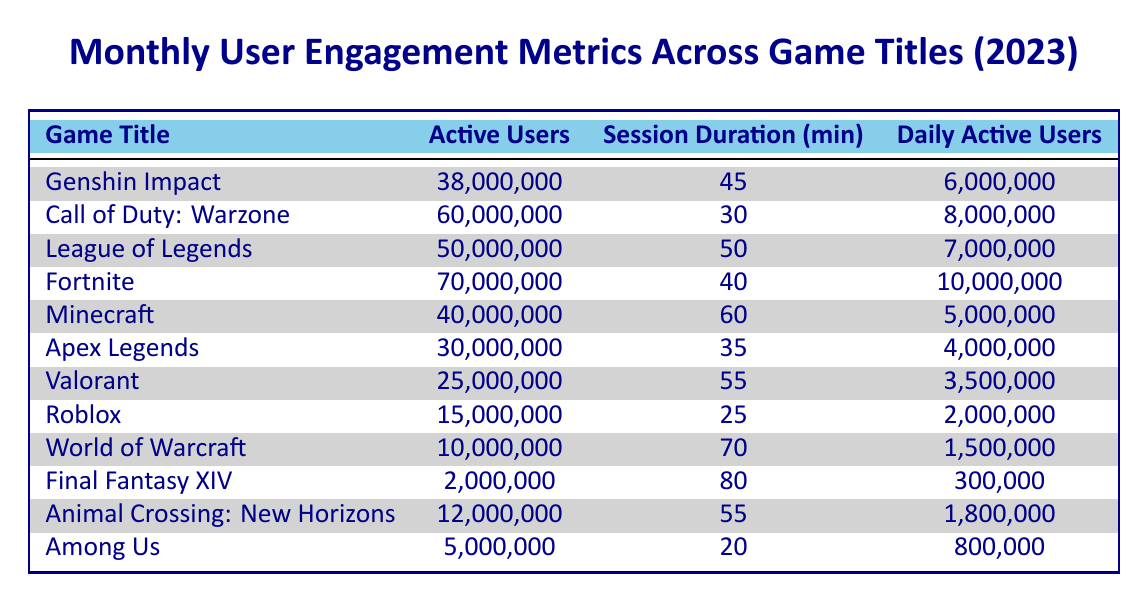What is the game title with the highest number of active users in January? The table shows that the game title with the highest number of active users in January is "Fortnite," with 70,000,000 active users.
Answer: Fortnite What is the session duration for "League of Legends"? "League of Legends" has a session duration of 50 minutes, as listed in the table under the corresponding game title.
Answer: 50 minutes How many total active users are there across all games listed for February? The total active users for February can be computed by adding up all the active users for each game: 40,000,000 (Minecraft) + 30,000,000 (Apex Legends) + 25,000,000 (Valorant) + 15,000,000 (Roblox) = 110,000,000.
Answer: 110,000,000 Is "World of Warcraft" among the top four games by active users in March? Based on the numbers in the table, "World of Warcraft" has 10,000,000 active users, which ranks lower than the other listed games for March, thus it's not in the top four.
Answer: No What is the average session duration for all the games listed in January? To find the average session duration, sum the session durations (45 + 30 + 50 + 40) and divide by the number of games (4): (45 + 30 + 50 + 40) = 165, and 165 / 4 = 41.25 minutes.
Answer: 41.25 minutes What is the difference in daily active users between "Call of Duty: Warzone" and "Among Us"? "Call of Duty: Warzone" has 8,000,000 daily active users while "Among Us" has 800,000. The difference can be calculated by subtracting: 8,000,000 - 800,000 = 7,200,000.
Answer: 7,200,000 Is the daily active user count for "Final Fantasy XIV" greater than 500,000? The daily active user count for "Final Fantasy XIV" is 300,000, which is less than 500,000.
Answer: No Which game title had the longest session duration in March? From the table data, "Final Fantasy XIV" has the longest session duration of 80 minutes, listed under March.
Answer: Final Fantasy XIV 